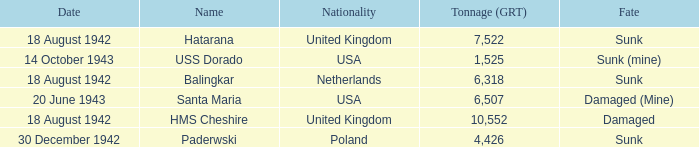What is the nationality of the HMS Cheshire? United Kingdom. 